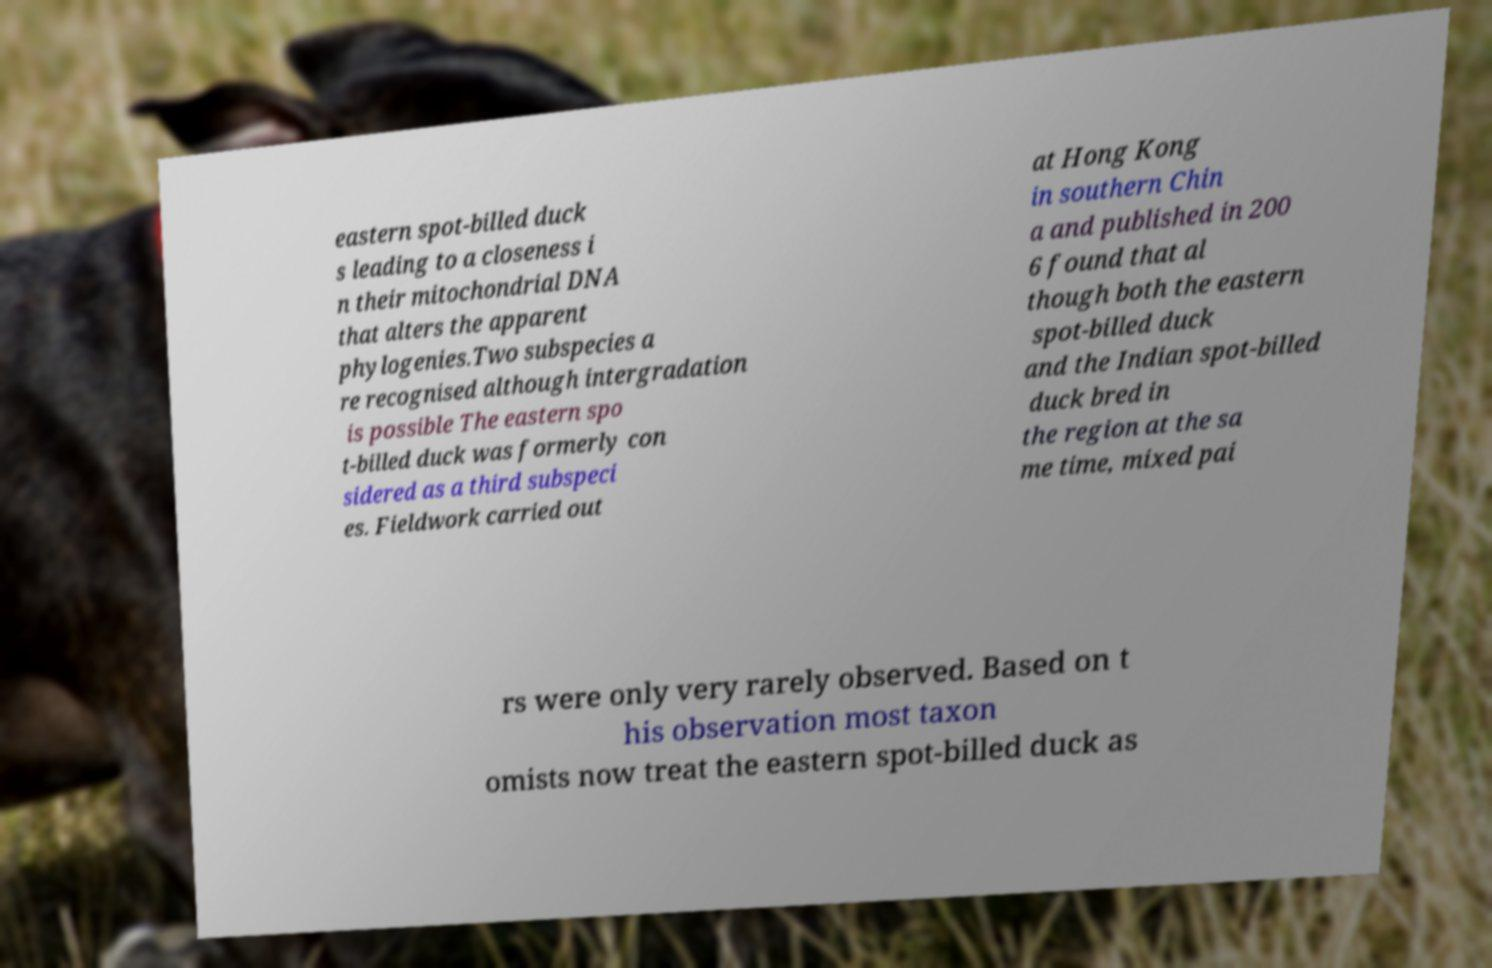I need the written content from this picture converted into text. Can you do that? eastern spot-billed duck s leading to a closeness i n their mitochondrial DNA that alters the apparent phylogenies.Two subspecies a re recognised although intergradation is possible The eastern spo t-billed duck was formerly con sidered as a third subspeci es. Fieldwork carried out at Hong Kong in southern Chin a and published in 200 6 found that al though both the eastern spot-billed duck and the Indian spot-billed duck bred in the region at the sa me time, mixed pai rs were only very rarely observed. Based on t his observation most taxon omists now treat the eastern spot-billed duck as 